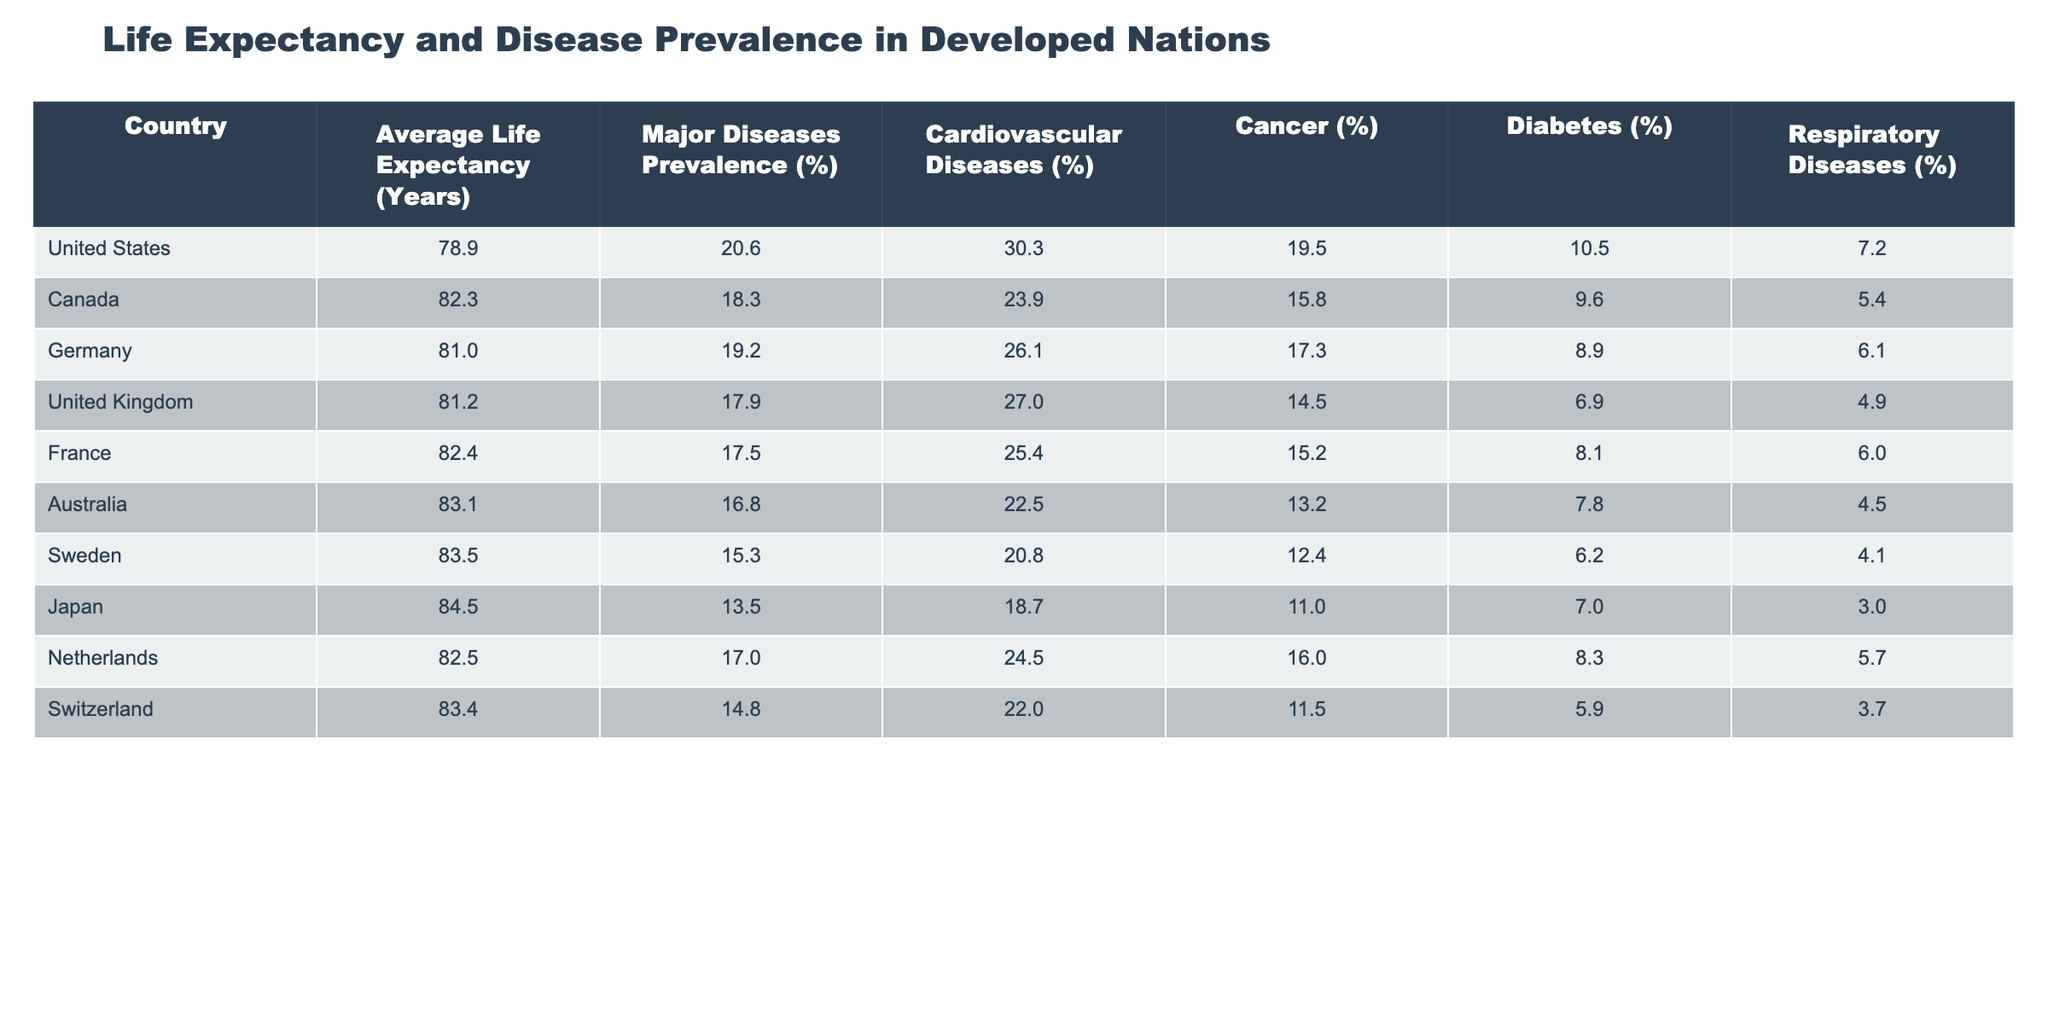What is the average life expectancy in Japan? The table indicates that Japan has an average life expectancy of 84.5 years.
Answer: 84.5 Which country has the highest prevalence of major diseases? According to the table, the United States has the highest prevalence of major diseases at 20.6%.
Answer: United States What is the difference in average life expectancy between Australia and the United Kingdom? The average life expectancy in Australia is 83.1 years, and in the United Kingdom, it is 81.2 years. The difference is calculated as 83.1 - 81.2 = 1.9 years.
Answer: 1.9 Is the prevalence of cancer in Germany greater than that in France? The table shows that the prevalence of cancer in Germany is 17.3%, while in France, it is 15.2%. Therefore, the statement is true.
Answer: Yes What country has the lowest prevalence of respiratory diseases? From the table, Japan has the lowest prevalence of respiratory diseases at 3.0%.
Answer: Japan What is the average prevalence of diabetes in the listed countries? The prevalence of diabetes values from the table are: 10.5, 9.6, 8.9, 6.9, 8.1, 7.8, 6.2, 7.0, 8.3, 5.9. Adding these together gives 79.2, and dividing by 10 countries gives an average of 7.92%.
Answer: 7.9 Which country has a higher prevalence of cardiovascular diseases, Canada or the Netherlands? The prevalence of cardiovascular diseases in Canada is 23.9%, while in the Netherlands, it is 24.5%. Therefore, the prevalence is higher in the Netherlands.
Answer: Netherlands Are respiratory diseases less prevalent in Sweden compared to Australia? The table indicates that respiratory diseases have a prevalence of 4.1% in Sweden and 4.5% in Australia. So, the statement is true as Sweden has lower prevalence.
Answer: Yes What is the average life expectancy of the three countries with the highest life expectancy? The countries with the highest life expectancies are Japan (84.5), Sweden (83.5), and Australia (83.1). Summing these gives 251.1, and dividing by 3 results in an average of 83.7 years.
Answer: 83.7 